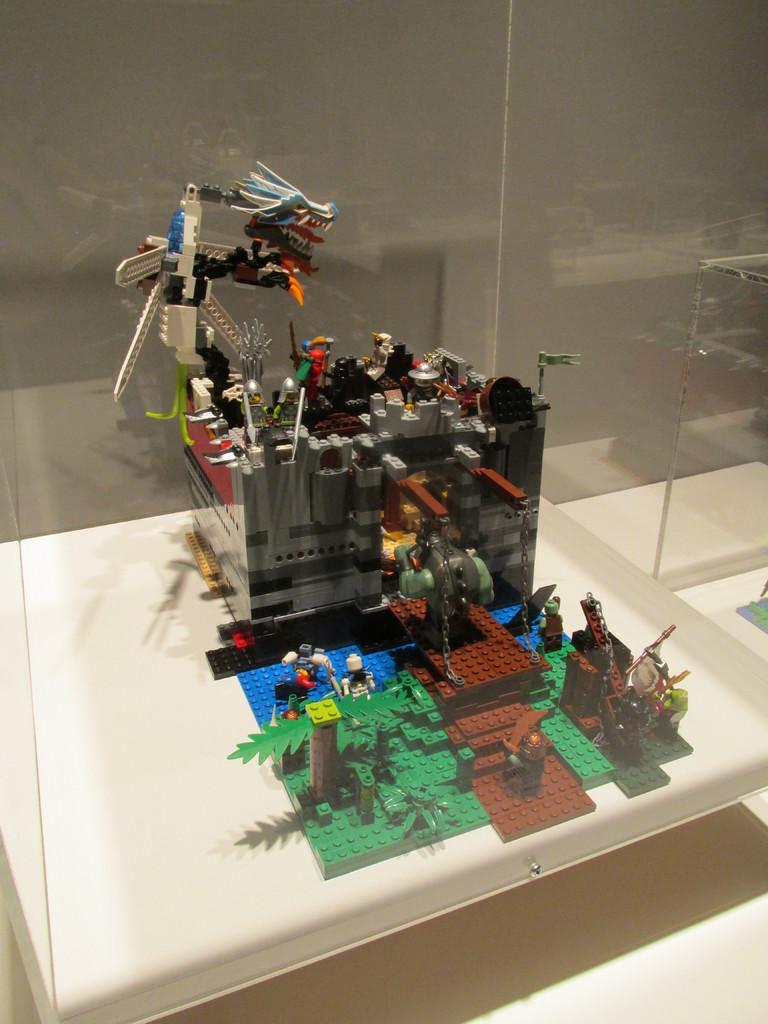What is the main subject in the center of the image? There is a lego in the center of the image. What color is the surface on which the lego is placed? The lego is on a white color surface. What can be seen in the background of the image? There is a wall in the background of the image. Can you tell me the total amount of the order placed for the lego in the image? There is no information about an order or its cost in the image, as it only shows a lego on a white surface with a wall in the background. 